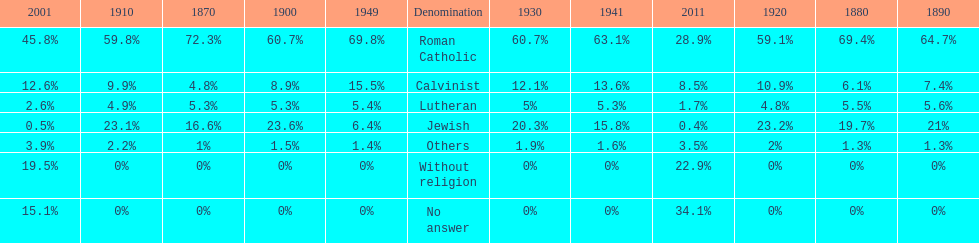Which denomination has the highest margin? Roman Catholic. 